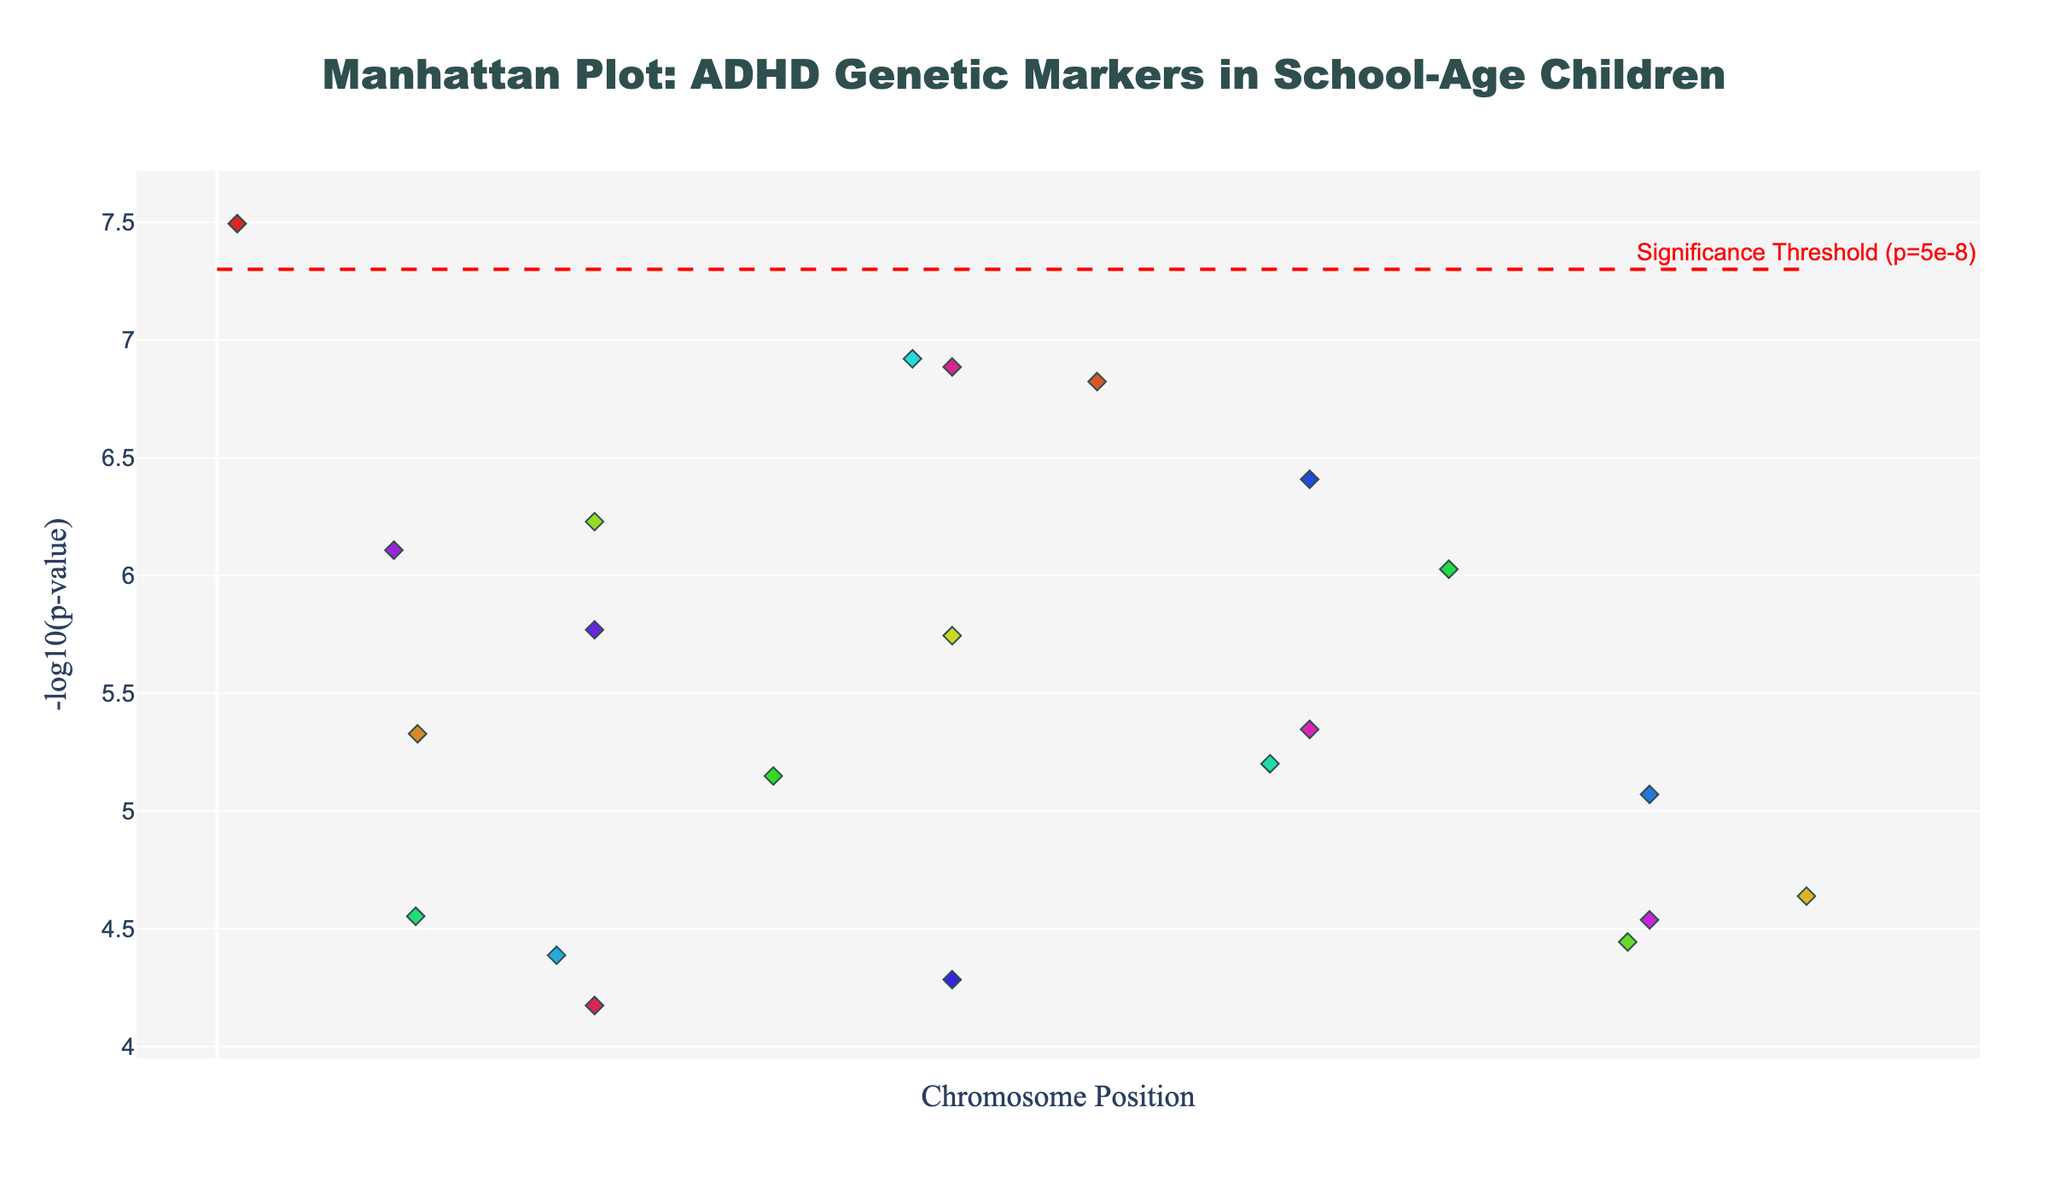What's the title of the plot? The title is placed at the top center of the figure and reads "Manhattan Plot: ADHD Genetic Markers in School-Age Children"
Answer: Manhattan Plot: ADHD Genetic Markers in School-Age Children Which chromosome shows the highest point in the plot? Chromosome 1 has a point with the highest -log10(p-value), specifically at position 1254367, as denoted by the labeled gene ADGRL3
Answer: Chromosome 1 What gene is associated with the smallest p-value? The smallest p-value is associated with the highest -log10(p-value) bar. In this case, it's ADGRL3 on Chromosome 1 indicated at position 1254367.
Answer: ADGRL3 Are there any genes that exceed the significance threshold? The significance threshold is marked by a dashed red horizontal line. ADGRL3 on Chromosome 1 crosses this threshold.
Answer: Yes, ADGRL3 How many chromosomes are represented in the plot? Each unique color represents a different chromosome, and they range from 1 to 22.
Answer: 22 Which gene on Chromosome 12 has a lower p-value between GRIN2A and TPH2? By looking at Chromosome 12, compare the -log10(p-values) of GRIN2A and TPH2; TPH2 appears to have a lower p-value because its -log10(p-value) is higher.
Answer: TPH2 Which gene on Chromosome 21 is significant or close to significance? Check the gene associated with Chromosome 21 and see its position relative to the significance threshold. CACNA1C is near the significance threshold.
Answer: CACNA1C How many genes have a p-value less than 1e-06? Identify the -log10(p-value) that corresponds to 1e-06, which is 6. Count all points above this value.
Answer: 7 Which genes are positioned on Chromosome 5? Locate Chromosome 5 along the x-axis and check the points labeled with gene names. There's only one, DAT1.
Answer: DAT1 How does the position of SLC6A4 on Chromosome 17 compare to that of COMT on Chromosome 6? SLC6A4's position on Chromosome 17 is at 23456789, which is the same position as COMT on Chromosome 6.
Answer: They are both at 23456789 